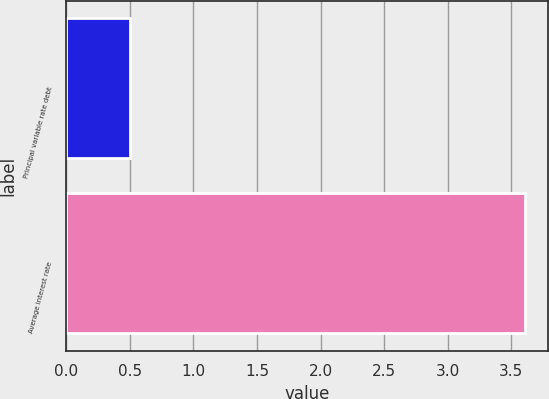<chart> <loc_0><loc_0><loc_500><loc_500><bar_chart><fcel>Principal variable rate debt<fcel>Average interest rate<nl><fcel>0.5<fcel>3.61<nl></chart> 